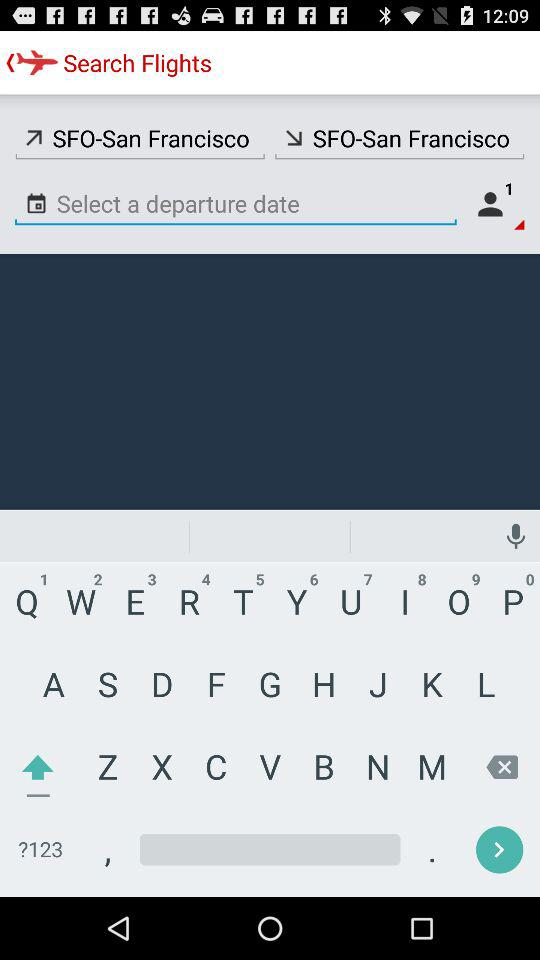Flight is from which city? The flight is from San Francisco. 